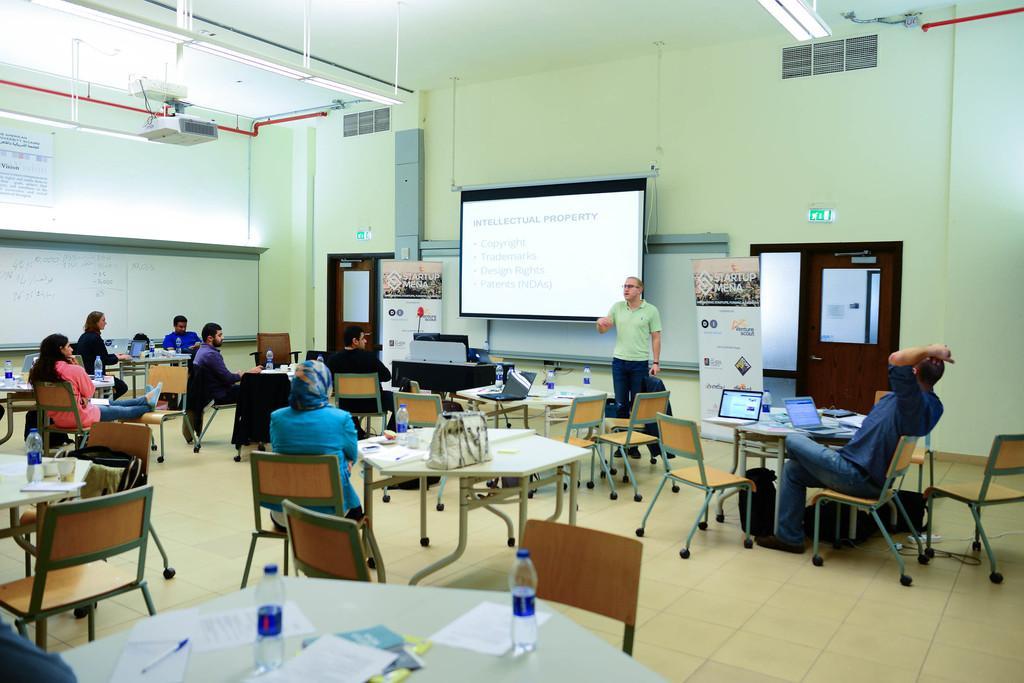Could you give a brief overview of what you see in this image? As we can see in the image there is a wall, screen, door, few people sitting here and there and there are chairs and tables. On tables there are laptops, bags and bottles. 